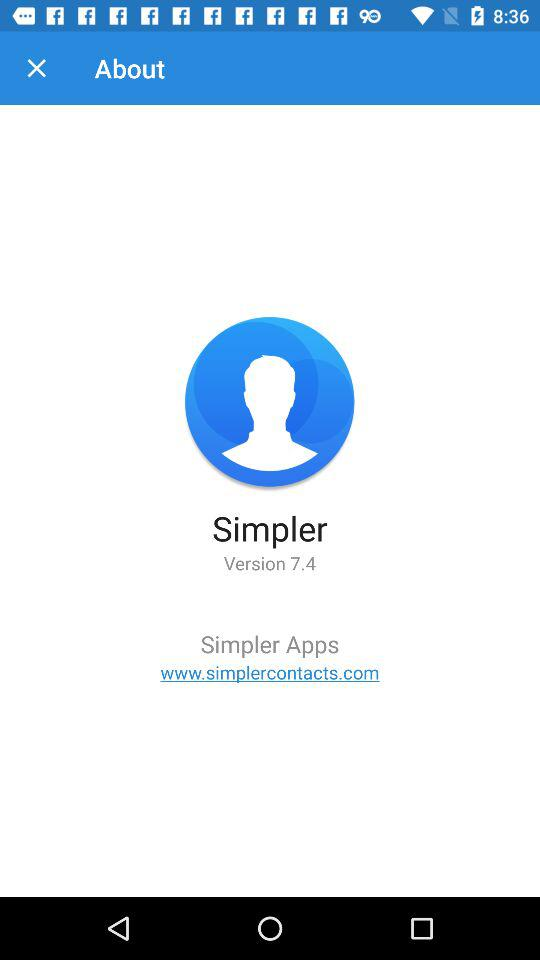What is the version of the application? The version of the application is 7.4. 